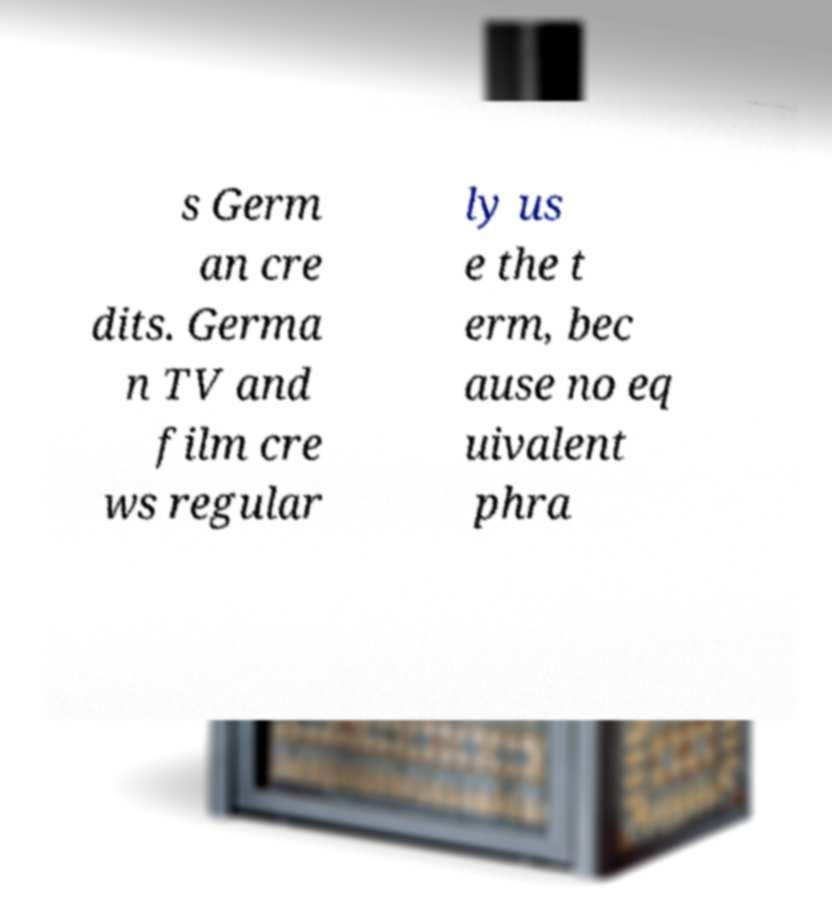Could you extract and type out the text from this image? s Germ an cre dits. Germa n TV and film cre ws regular ly us e the t erm, bec ause no eq uivalent phra 